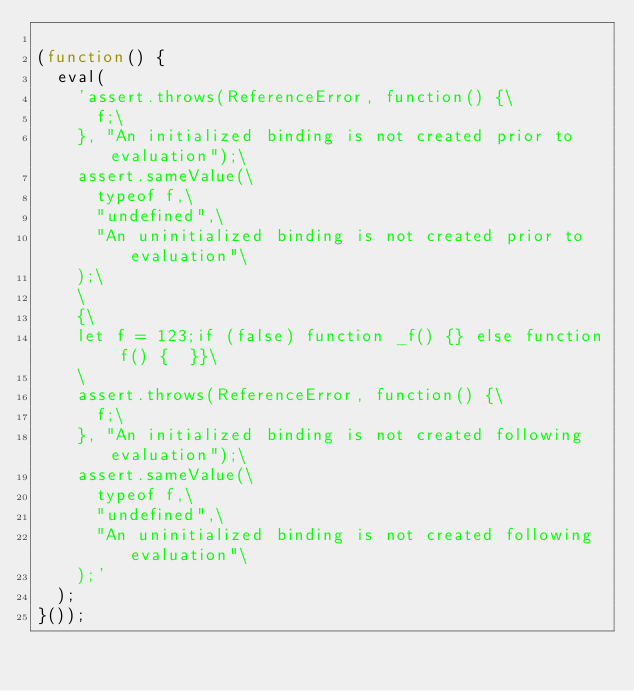<code> <loc_0><loc_0><loc_500><loc_500><_JavaScript_>
(function() {
  eval(
    'assert.throws(ReferenceError, function() {\
      f;\
    }, "An initialized binding is not created prior to evaluation");\
    assert.sameValue(\
      typeof f,\
      "undefined",\
      "An uninitialized binding is not created prior to evaluation"\
    );\
    \
    {\
    let f = 123;if (false) function _f() {} else function f() {  }}\
    \
    assert.throws(ReferenceError, function() {\
      f;\
    }, "An initialized binding is not created following evaluation");\
    assert.sameValue(\
      typeof f,\
      "undefined",\
      "An uninitialized binding is not created following evaluation"\
    );'
  );
}());
</code> 